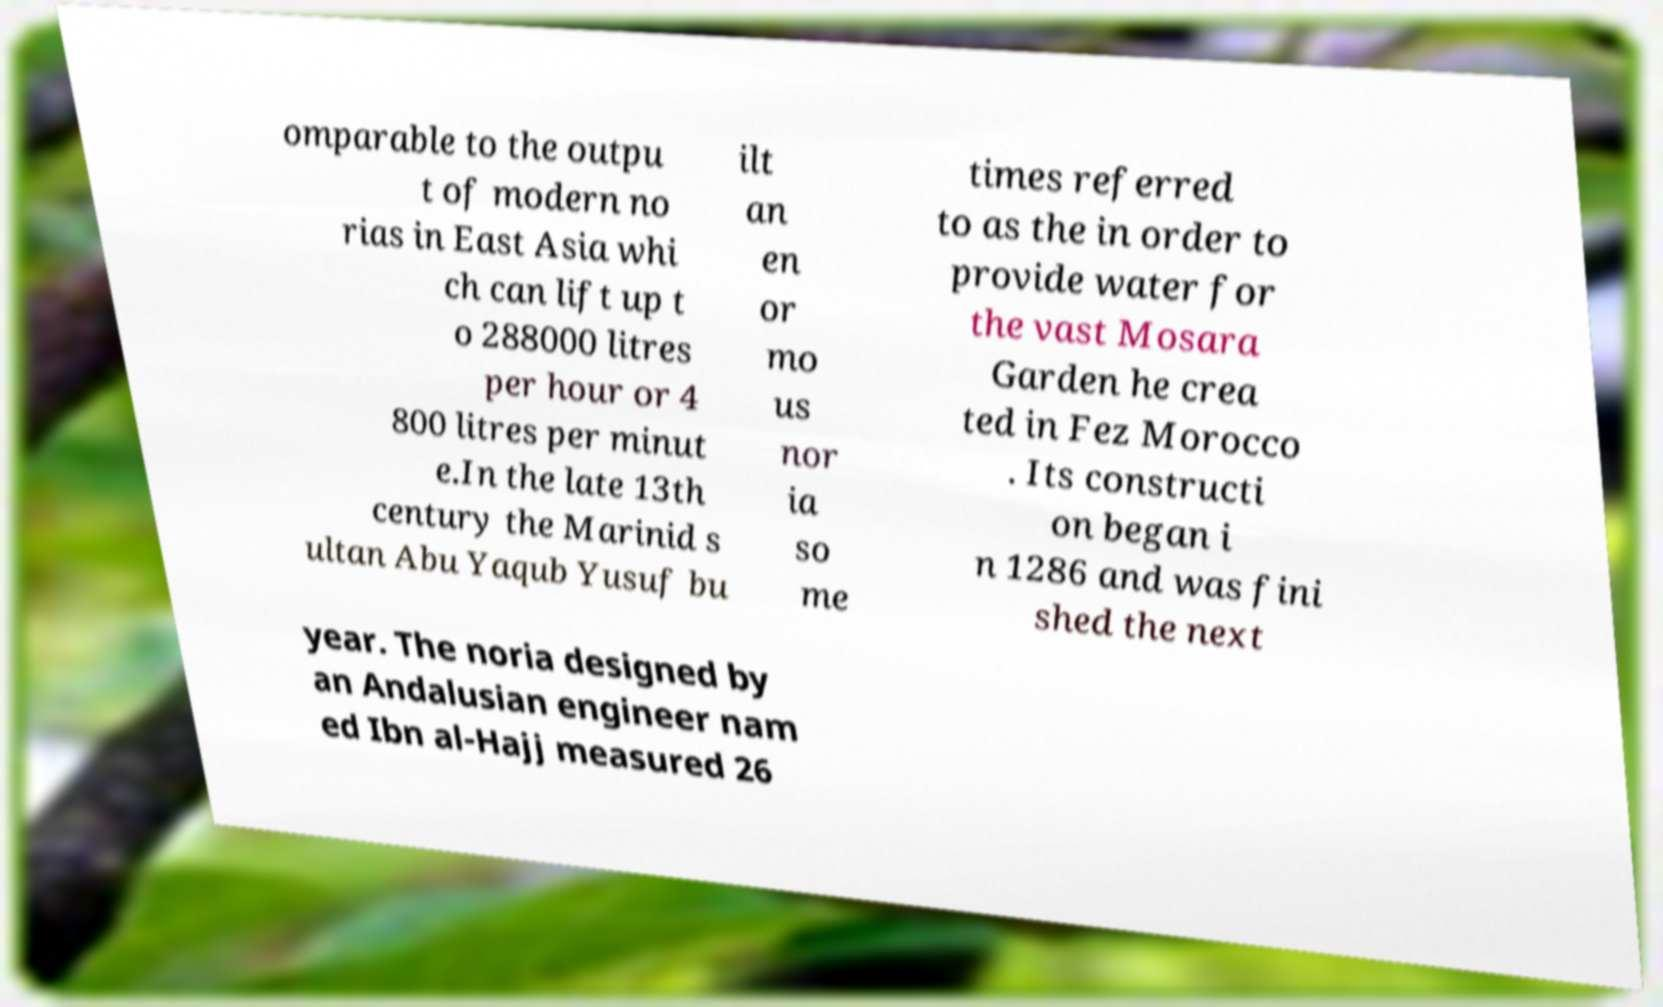Please read and relay the text visible in this image. What does it say? omparable to the outpu t of modern no rias in East Asia whi ch can lift up t o 288000 litres per hour or 4 800 litres per minut e.In the late 13th century the Marinid s ultan Abu Yaqub Yusuf bu ilt an en or mo us nor ia so me times referred to as the in order to provide water for the vast Mosara Garden he crea ted in Fez Morocco . Its constructi on began i n 1286 and was fini shed the next year. The noria designed by an Andalusian engineer nam ed Ibn al-Hajj measured 26 